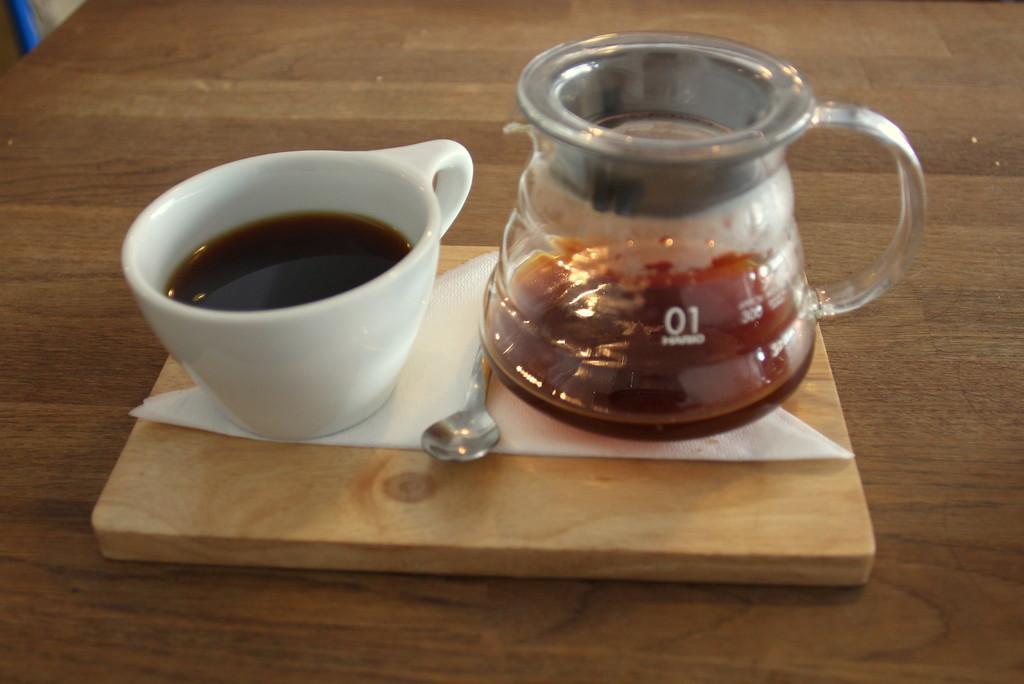Can you describe this image briefly? Here we can see two cups with liquid in it and a spoon on a tissue paper on a wooden board on a platform. On the left at the top corner we can see an object. 